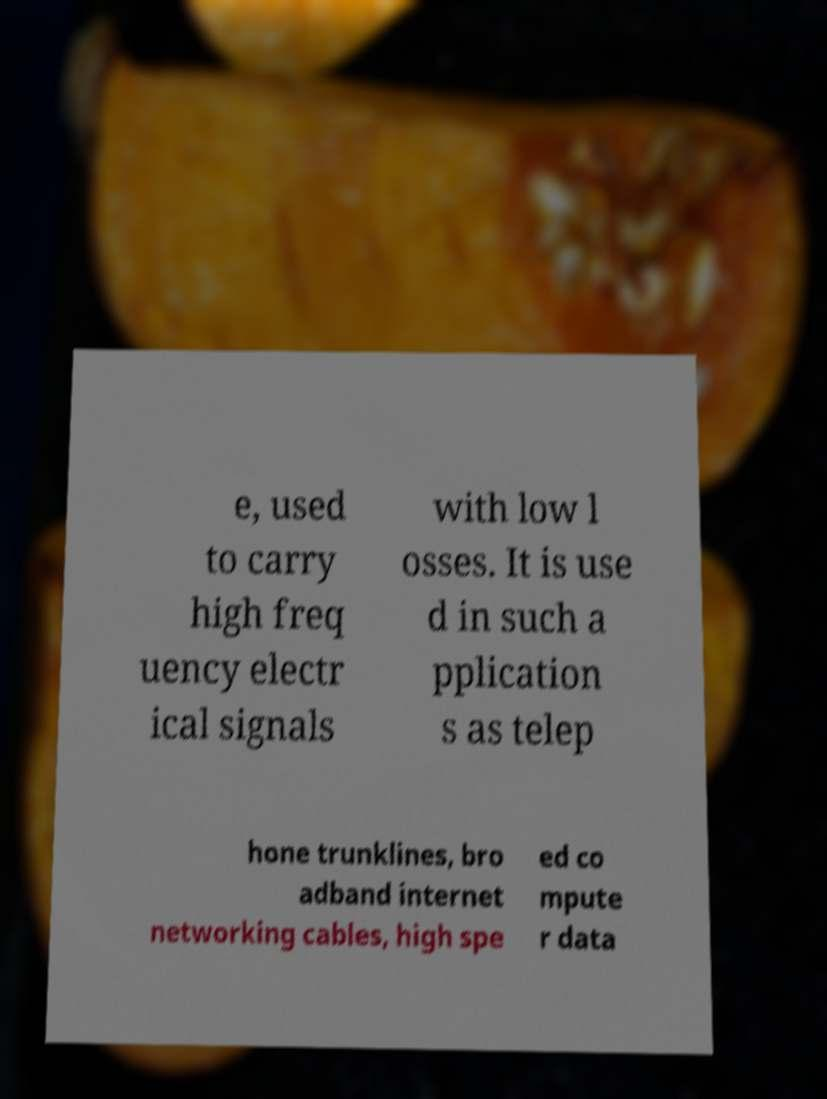Please identify and transcribe the text found in this image. e, used to carry high freq uency electr ical signals with low l osses. It is use d in such a pplication s as telep hone trunklines, bro adband internet networking cables, high spe ed co mpute r data 